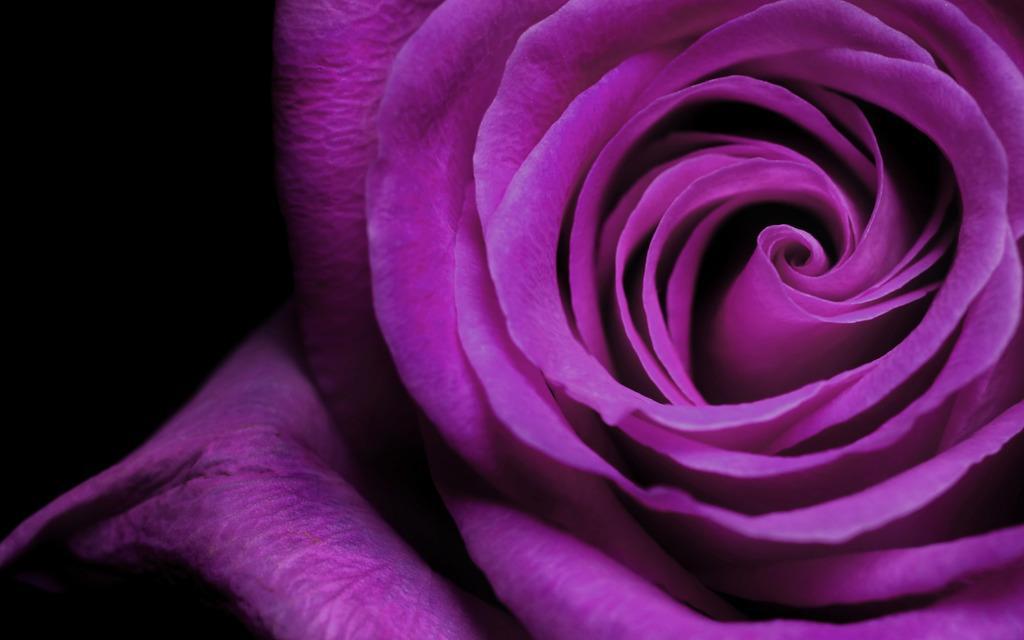In one or two sentences, can you explain what this image depicts? In this image we can see a rose which is in purple color. 